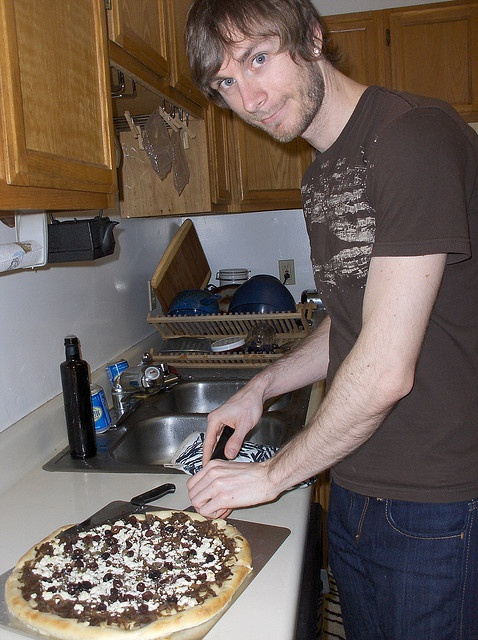Describe the objects in this image and their specific colors. I can see people in tan, black, and darkgray tones, pizza in tan, lightgray, gray, maroon, and darkgray tones, sink in tan, black, gray, and darkgray tones, bottle in tan, black, gray, and navy tones, and sink in tan, black, gray, and darkgray tones in this image. 